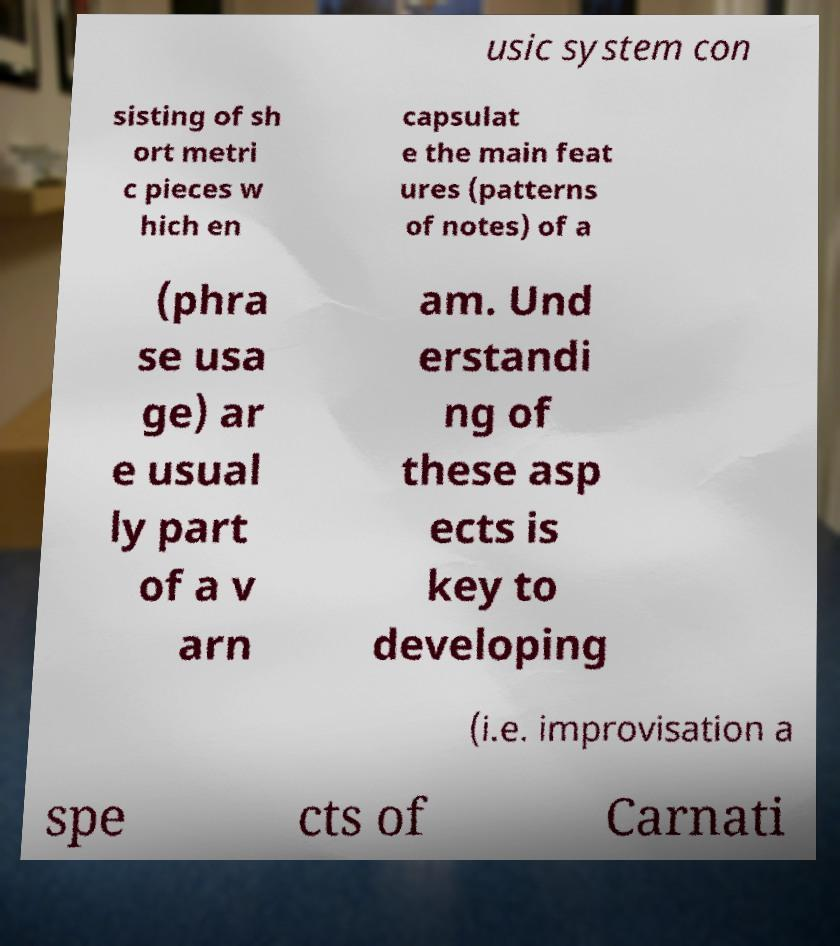For documentation purposes, I need the text within this image transcribed. Could you provide that? usic system con sisting of sh ort metri c pieces w hich en capsulat e the main feat ures (patterns of notes) of a (phra se usa ge) ar e usual ly part of a v arn am. Und erstandi ng of these asp ects is key to developing (i.e. improvisation a spe cts of Carnati 